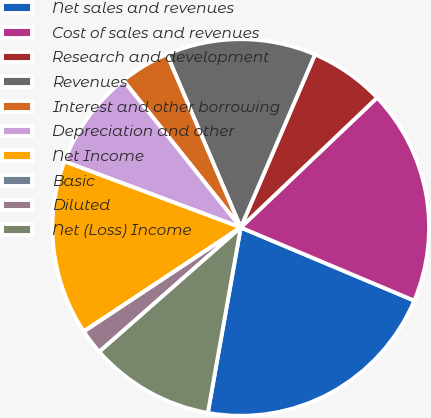<chart> <loc_0><loc_0><loc_500><loc_500><pie_chart><fcel>Net sales and revenues<fcel>Cost of sales and revenues<fcel>Research and development<fcel>Revenues<fcel>Interest and other borrowing<fcel>Depreciation and other<fcel>Net Income<fcel>Basic<fcel>Diluted<fcel>Net (Loss) Income<nl><fcel>21.45%<fcel>18.46%<fcel>6.44%<fcel>12.87%<fcel>4.3%<fcel>8.58%<fcel>15.02%<fcel>0.01%<fcel>2.15%<fcel>10.73%<nl></chart> 